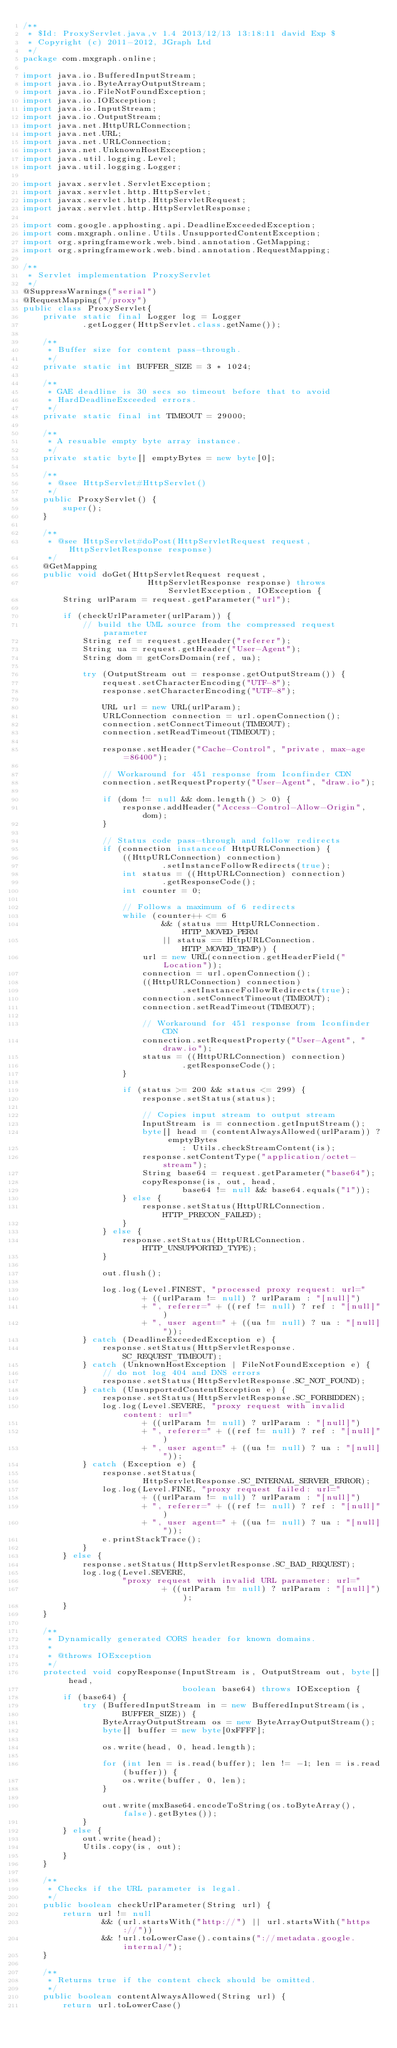Convert code to text. <code><loc_0><loc_0><loc_500><loc_500><_Java_>/**
 * $Id: ProxyServlet.java,v 1.4 2013/12/13 13:18:11 david Exp $
 * Copyright (c) 2011-2012, JGraph Ltd
 */
package com.mxgraph.online;

import java.io.BufferedInputStream;
import java.io.ByteArrayOutputStream;
import java.io.FileNotFoundException;
import java.io.IOException;
import java.io.InputStream;
import java.io.OutputStream;
import java.net.HttpURLConnection;
import java.net.URL;
import java.net.URLConnection;
import java.net.UnknownHostException;
import java.util.logging.Level;
import java.util.logging.Logger;

import javax.servlet.ServletException;
import javax.servlet.http.HttpServlet;
import javax.servlet.http.HttpServletRequest;
import javax.servlet.http.HttpServletResponse;

import com.google.apphosting.api.DeadlineExceededException;
import com.mxgraph.online.Utils.UnsupportedContentException;
import org.springframework.web.bind.annotation.GetMapping;
import org.springframework.web.bind.annotation.RequestMapping;

/**
 * Servlet implementation ProxyServlet
 */
@SuppressWarnings("serial")
@RequestMapping("/proxy")
public class ProxyServlet{
    private static final Logger log = Logger
            .getLogger(HttpServlet.class.getName());

    /**
     * Buffer size for content pass-through.
     */
    private static int BUFFER_SIZE = 3 * 1024;

    /**
     * GAE deadline is 30 secs so timeout before that to avoid
     * HardDeadlineExceeded errors.
     */
    private static final int TIMEOUT = 29000;

    /**
     * A resuable empty byte array instance.
     */
    private static byte[] emptyBytes = new byte[0];

    /**
     * @see HttpServlet#HttpServlet()
     */
    public ProxyServlet() {
        super();
    }

    /**
     * @see HttpServlet#doPost(HttpServletRequest request, HttpServletResponse response)
     */
    @GetMapping
    public void doGet(HttpServletRequest request,
                         HttpServletResponse response) throws ServletException, IOException {
        String urlParam = request.getParameter("url");

        if (checkUrlParameter(urlParam)) {
            // build the UML source from the compressed request parameter
            String ref = request.getHeader("referer");
            String ua = request.getHeader("User-Agent");
            String dom = getCorsDomain(ref, ua);

            try (OutputStream out = response.getOutputStream()) {
                request.setCharacterEncoding("UTF-8");
                response.setCharacterEncoding("UTF-8");

                URL url = new URL(urlParam);
                URLConnection connection = url.openConnection();
                connection.setConnectTimeout(TIMEOUT);
                connection.setReadTimeout(TIMEOUT);

                response.setHeader("Cache-Control", "private, max-age=86400");

                // Workaround for 451 response from Iconfinder CDN
                connection.setRequestProperty("User-Agent", "draw.io");

                if (dom != null && dom.length() > 0) {
                    response.addHeader("Access-Control-Allow-Origin", dom);
                }

                // Status code pass-through and follow redirects
                if (connection instanceof HttpURLConnection) {
                    ((HttpURLConnection) connection)
                            .setInstanceFollowRedirects(true);
                    int status = ((HttpURLConnection) connection)
                            .getResponseCode();
                    int counter = 0;

                    // Follows a maximum of 6 redirects
                    while (counter++ <= 6
                            && (status == HttpURLConnection.HTTP_MOVED_PERM
                            || status == HttpURLConnection.HTTP_MOVED_TEMP)) {
                        url = new URL(connection.getHeaderField("Location"));
                        connection = url.openConnection();
                        ((HttpURLConnection) connection)
                                .setInstanceFollowRedirects(true);
                        connection.setConnectTimeout(TIMEOUT);
                        connection.setReadTimeout(TIMEOUT);

                        // Workaround for 451 response from Iconfinder CDN
                        connection.setRequestProperty("User-Agent", "draw.io");
                        status = ((HttpURLConnection) connection)
                                .getResponseCode();
                    }

                    if (status >= 200 && status <= 299) {
                        response.setStatus(status);

                        // Copies input stream to output stream
                        InputStream is = connection.getInputStream();
                        byte[] head = (contentAlwaysAllowed(urlParam)) ? emptyBytes
                                : Utils.checkStreamContent(is);
                        response.setContentType("application/octet-stream");
                        String base64 = request.getParameter("base64");
                        copyResponse(is, out, head,
                                base64 != null && base64.equals("1"));
                    } else {
                        response.setStatus(HttpURLConnection.HTTP_PRECON_FAILED);
                    }
                } else {
                    response.setStatus(HttpURLConnection.HTTP_UNSUPPORTED_TYPE);
                }

                out.flush();

                log.log(Level.FINEST, "processed proxy request: url="
                        + ((urlParam != null) ? urlParam : "[null]")
                        + ", referer=" + ((ref != null) ? ref : "[null]")
                        + ", user agent=" + ((ua != null) ? ua : "[null]"));
            } catch (DeadlineExceededException e) {
                response.setStatus(HttpServletResponse.SC_REQUEST_TIMEOUT);
            } catch (UnknownHostException | FileNotFoundException e) {
                // do not log 404 and DNS errors
                response.setStatus(HttpServletResponse.SC_NOT_FOUND);
            } catch (UnsupportedContentException e) {
                response.setStatus(HttpServletResponse.SC_FORBIDDEN);
                log.log(Level.SEVERE, "proxy request with invalid content: url="
                        + ((urlParam != null) ? urlParam : "[null]")
                        + ", referer=" + ((ref != null) ? ref : "[null]")
                        + ", user agent=" + ((ua != null) ? ua : "[null]"));
            } catch (Exception e) {
                response.setStatus(
                        HttpServletResponse.SC_INTERNAL_SERVER_ERROR);
                log.log(Level.FINE, "proxy request failed: url="
                        + ((urlParam != null) ? urlParam : "[null]")
                        + ", referer=" + ((ref != null) ? ref : "[null]")
                        + ", user agent=" + ((ua != null) ? ua : "[null]"));
                e.printStackTrace();
            }
        } else {
            response.setStatus(HttpServletResponse.SC_BAD_REQUEST);
            log.log(Level.SEVERE,
                    "proxy request with invalid URL parameter: url="
                            + ((urlParam != null) ? urlParam : "[null]"));
        }
    }

    /**
     * Dynamically generated CORS header for known domains.
     *
     * @throws IOException
     */
    protected void copyResponse(InputStream is, OutputStream out, byte[] head,
                                boolean base64) throws IOException {
        if (base64) {
            try (BufferedInputStream in = new BufferedInputStream(is,
                    BUFFER_SIZE)) {
                ByteArrayOutputStream os = new ByteArrayOutputStream();
                byte[] buffer = new byte[0xFFFF];

                os.write(head, 0, head.length);

                for (int len = is.read(buffer); len != -1; len = is.read(buffer)) {
                    os.write(buffer, 0, len);
                }

                out.write(mxBase64.encodeToString(os.toByteArray(), false).getBytes());
            }
        } else {
            out.write(head);
            Utils.copy(is, out);
        }
    }

    /**
     * Checks if the URL parameter is legal.
     */
    public boolean checkUrlParameter(String url) {
        return url != null
                && (url.startsWith("http://") || url.startsWith("https://"))
                && !url.toLowerCase().contains("://metadata.google.internal/");
    }

    /**
     * Returns true if the content check should be omitted.
     */
    public boolean contentAlwaysAllowed(String url) {
        return url.toLowerCase()</code> 